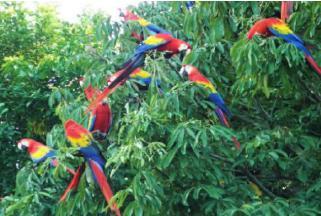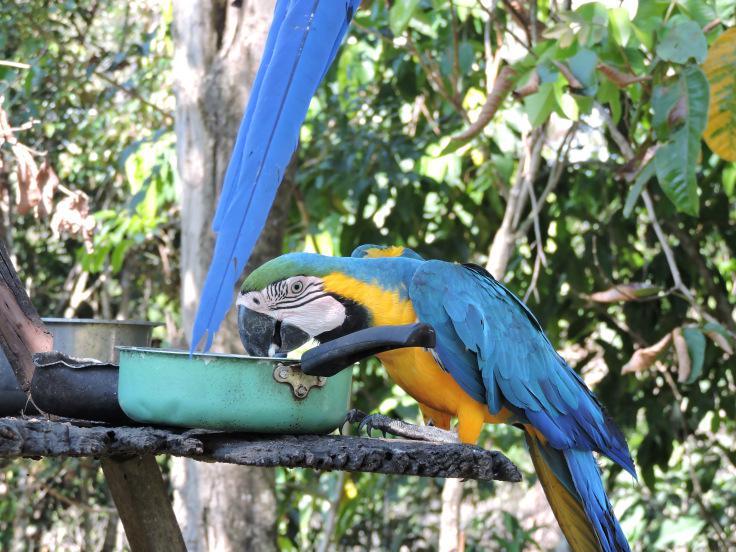The first image is the image on the left, the second image is the image on the right. Evaluate the accuracy of this statement regarding the images: "In one image there are four blue birds perched on a branch.". Is it true? Answer yes or no. No. The first image is the image on the left, the second image is the image on the right. For the images shown, is this caption "The right image features a blue-and-yellow parrot only, and the left image includes at least one red-headed parrot." true? Answer yes or no. Yes. 